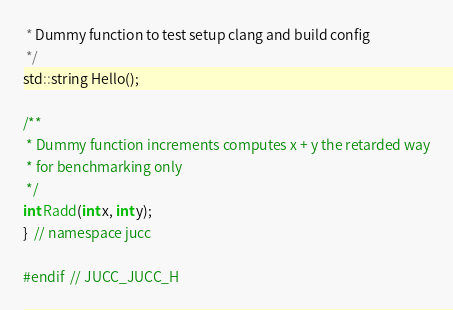Convert code to text. <code><loc_0><loc_0><loc_500><loc_500><_C_> * Dummy function to test setup clang and build config
 */
std::string Hello();

/**
 * Dummy function increments computes x + y the retarded way
 * for benchmarking only
 */
int Radd(int x, int y);
}  // namespace jucc

#endif  // JUCC_JUCC_H
</code> 